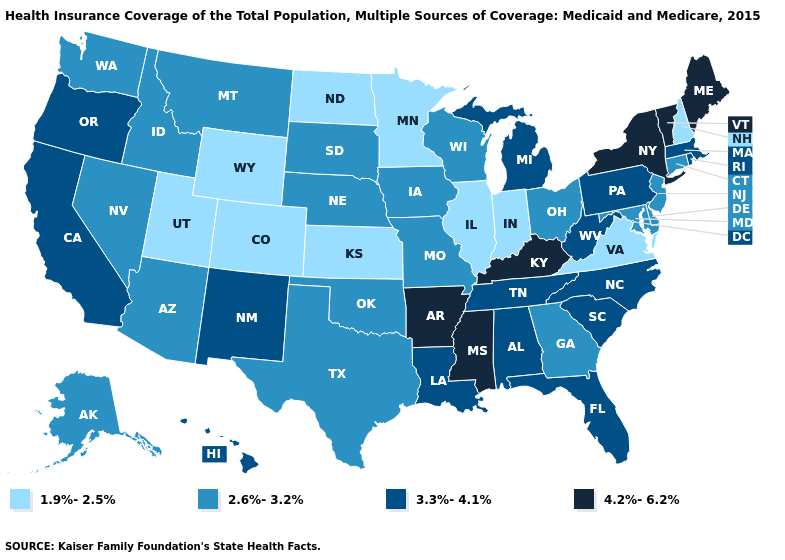What is the lowest value in states that border South Carolina?
Short answer required. 2.6%-3.2%. Does the map have missing data?
Be succinct. No. What is the value of Maine?
Short answer required. 4.2%-6.2%. What is the value of Idaho?
Quick response, please. 2.6%-3.2%. Name the states that have a value in the range 4.2%-6.2%?
Write a very short answer. Arkansas, Kentucky, Maine, Mississippi, New York, Vermont. Which states have the lowest value in the South?
Concise answer only. Virginia. Does the first symbol in the legend represent the smallest category?
Answer briefly. Yes. What is the lowest value in the USA?
Short answer required. 1.9%-2.5%. What is the value of Kansas?
Short answer required. 1.9%-2.5%. Does the first symbol in the legend represent the smallest category?
Short answer required. Yes. What is the highest value in the USA?
Give a very brief answer. 4.2%-6.2%. What is the value of Hawaii?
Quick response, please. 3.3%-4.1%. Does Kansas have the same value as Colorado?
Give a very brief answer. Yes. Does Maine have the highest value in the USA?
Quick response, please. Yes. Name the states that have a value in the range 4.2%-6.2%?
Write a very short answer. Arkansas, Kentucky, Maine, Mississippi, New York, Vermont. 